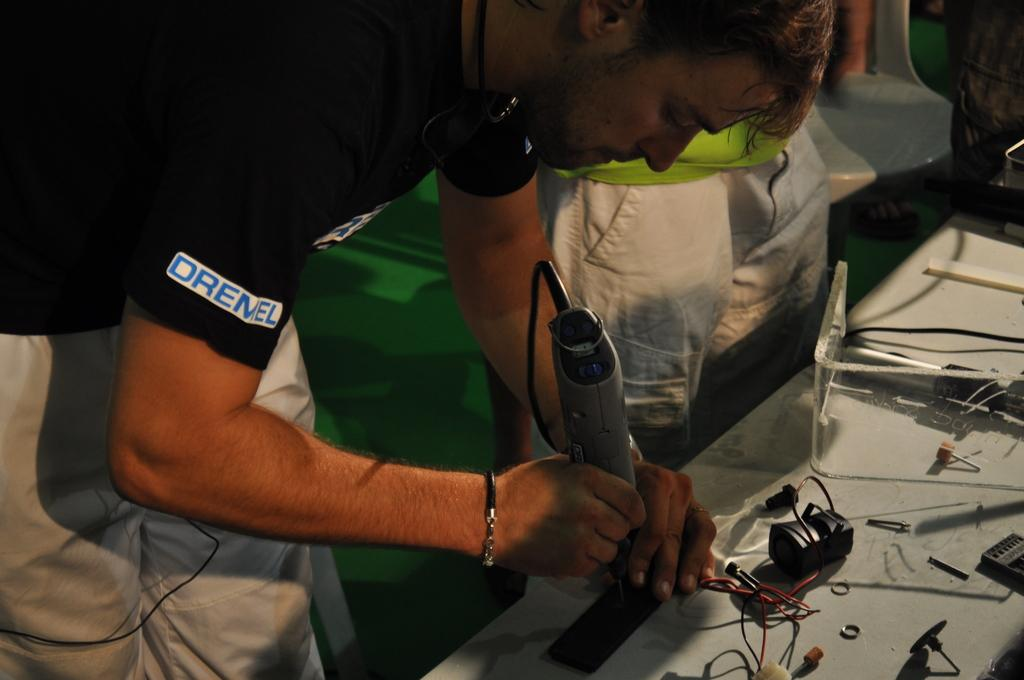<image>
Share a concise interpretation of the image provided. A man s using a handtool while wearing an Oremel shirt. 